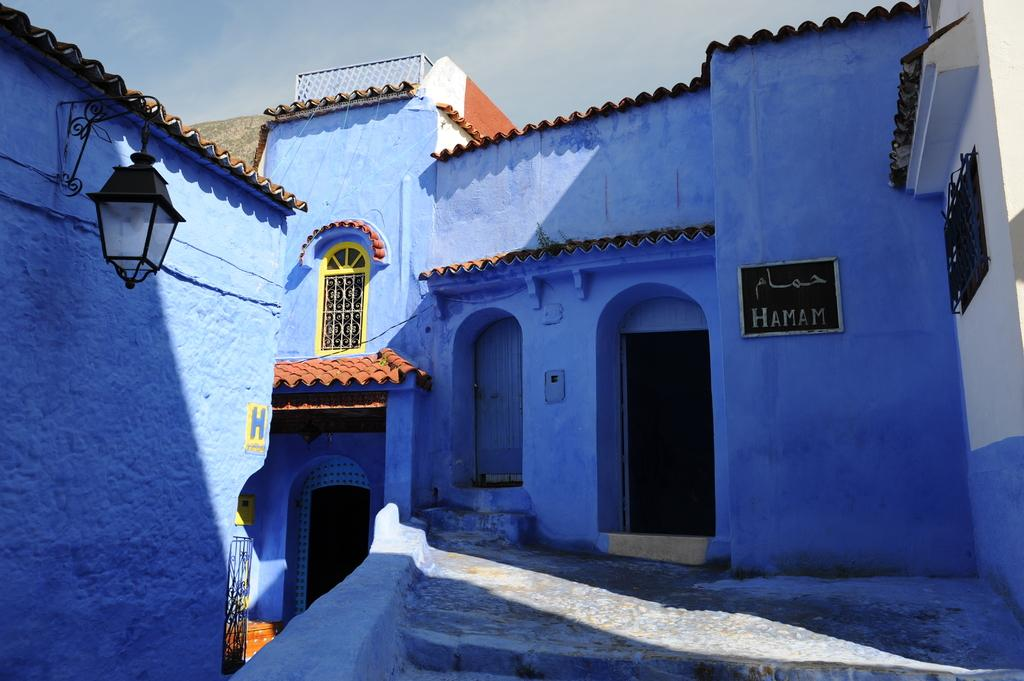What type of structure is in the picture? There is a house in the picture. What object can be seen near the house? There is a board in the picture. Where is the window located in the picture? There is a window on the left side of the picture. What is near the window? There is a light near the window. What can be seen at the top of the picture? The sky is visible at the top of the picture. How many entrances are visible in the picture? There is a door in the picture, which is an entrance. What force is being applied to the house in the picture? There is no force being applied to the house in the picture; it is stationary. What class of people might live in the house in the picture? There is no information about the inhabitants of the house in the picture, so it cannot be determined what class of people might live there. 